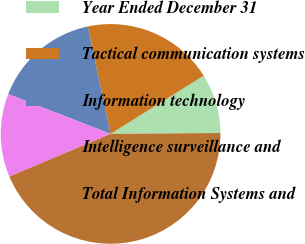<chart> <loc_0><loc_0><loc_500><loc_500><pie_chart><fcel>Year Ended December 31<fcel>Tactical communication systems<fcel>Information technology<fcel>Intelligence surveillance and<fcel>Total Information Systems and<nl><fcel>8.76%<fcel>19.43%<fcel>15.76%<fcel>12.26%<fcel>43.78%<nl></chart> 